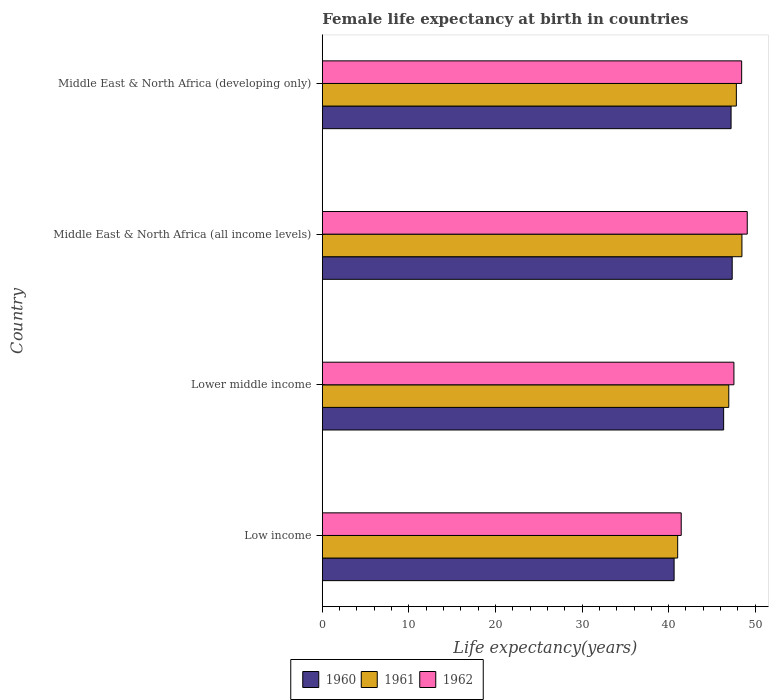How many different coloured bars are there?
Offer a very short reply. 3. How many groups of bars are there?
Provide a short and direct response. 4. How many bars are there on the 3rd tick from the top?
Your answer should be very brief. 3. How many bars are there on the 3rd tick from the bottom?
Offer a terse response. 3. What is the label of the 3rd group of bars from the top?
Provide a succinct answer. Lower middle income. What is the female life expectancy at birth in 1960 in Middle East & North Africa (developing only)?
Your answer should be very brief. 47.21. Across all countries, what is the maximum female life expectancy at birth in 1961?
Offer a terse response. 48.47. Across all countries, what is the minimum female life expectancy at birth in 1961?
Offer a terse response. 41.04. In which country was the female life expectancy at birth in 1960 maximum?
Provide a short and direct response. Middle East & North Africa (all income levels). In which country was the female life expectancy at birth in 1960 minimum?
Your answer should be compact. Low income. What is the total female life expectancy at birth in 1961 in the graph?
Give a very brief answer. 184.29. What is the difference between the female life expectancy at birth in 1960 in Middle East & North Africa (all income levels) and that in Middle East & North Africa (developing only)?
Offer a terse response. 0.13. What is the difference between the female life expectancy at birth in 1960 in Middle East & North Africa (developing only) and the female life expectancy at birth in 1962 in Low income?
Offer a terse response. 5.76. What is the average female life expectancy at birth in 1961 per country?
Keep it short and to the point. 46.07. What is the difference between the female life expectancy at birth in 1961 and female life expectancy at birth in 1960 in Low income?
Give a very brief answer. 0.41. What is the ratio of the female life expectancy at birth in 1960 in Lower middle income to that in Middle East & North Africa (all income levels)?
Provide a succinct answer. 0.98. What is the difference between the highest and the second highest female life expectancy at birth in 1962?
Ensure brevity in your answer.  0.65. What is the difference between the highest and the lowest female life expectancy at birth in 1960?
Ensure brevity in your answer.  6.71. What does the 1st bar from the top in Middle East & North Africa (all income levels) represents?
Ensure brevity in your answer.  1962. What does the 3rd bar from the bottom in Middle East & North Africa (all income levels) represents?
Provide a succinct answer. 1962. Are all the bars in the graph horizontal?
Keep it short and to the point. Yes. What is the difference between two consecutive major ticks on the X-axis?
Give a very brief answer. 10. Does the graph contain grids?
Keep it short and to the point. No. Where does the legend appear in the graph?
Give a very brief answer. Bottom center. What is the title of the graph?
Make the answer very short. Female life expectancy at birth in countries. What is the label or title of the X-axis?
Your answer should be very brief. Life expectancy(years). What is the label or title of the Y-axis?
Provide a succinct answer. Country. What is the Life expectancy(years) of 1960 in Low income?
Offer a very short reply. 40.63. What is the Life expectancy(years) in 1961 in Low income?
Ensure brevity in your answer.  41.04. What is the Life expectancy(years) in 1962 in Low income?
Your answer should be very brief. 41.46. What is the Life expectancy(years) in 1960 in Lower middle income?
Make the answer very short. 46.36. What is the Life expectancy(years) of 1961 in Lower middle income?
Ensure brevity in your answer.  46.95. What is the Life expectancy(years) in 1962 in Lower middle income?
Your answer should be compact. 47.54. What is the Life expectancy(years) in 1960 in Middle East & North Africa (all income levels)?
Keep it short and to the point. 47.34. What is the Life expectancy(years) in 1961 in Middle East & North Africa (all income levels)?
Your response must be concise. 48.47. What is the Life expectancy(years) of 1962 in Middle East & North Africa (all income levels)?
Offer a very short reply. 49.08. What is the Life expectancy(years) in 1960 in Middle East & North Africa (developing only)?
Provide a short and direct response. 47.21. What is the Life expectancy(years) of 1961 in Middle East & North Africa (developing only)?
Provide a succinct answer. 47.82. What is the Life expectancy(years) in 1962 in Middle East & North Africa (developing only)?
Make the answer very short. 48.44. Across all countries, what is the maximum Life expectancy(years) of 1960?
Offer a terse response. 47.34. Across all countries, what is the maximum Life expectancy(years) in 1961?
Offer a very short reply. 48.47. Across all countries, what is the maximum Life expectancy(years) of 1962?
Keep it short and to the point. 49.08. Across all countries, what is the minimum Life expectancy(years) in 1960?
Keep it short and to the point. 40.63. Across all countries, what is the minimum Life expectancy(years) in 1961?
Offer a very short reply. 41.04. Across all countries, what is the minimum Life expectancy(years) of 1962?
Make the answer very short. 41.46. What is the total Life expectancy(years) of 1960 in the graph?
Provide a succinct answer. 181.55. What is the total Life expectancy(years) in 1961 in the graph?
Your answer should be very brief. 184.29. What is the total Life expectancy(years) in 1962 in the graph?
Keep it short and to the point. 186.52. What is the difference between the Life expectancy(years) of 1960 in Low income and that in Lower middle income?
Provide a succinct answer. -5.72. What is the difference between the Life expectancy(years) of 1961 in Low income and that in Lower middle income?
Offer a very short reply. -5.9. What is the difference between the Life expectancy(years) in 1962 in Low income and that in Lower middle income?
Your answer should be compact. -6.09. What is the difference between the Life expectancy(years) of 1960 in Low income and that in Middle East & North Africa (all income levels)?
Your answer should be compact. -6.71. What is the difference between the Life expectancy(years) in 1961 in Low income and that in Middle East & North Africa (all income levels)?
Ensure brevity in your answer.  -7.42. What is the difference between the Life expectancy(years) in 1962 in Low income and that in Middle East & North Africa (all income levels)?
Make the answer very short. -7.63. What is the difference between the Life expectancy(years) of 1960 in Low income and that in Middle East & North Africa (developing only)?
Keep it short and to the point. -6.58. What is the difference between the Life expectancy(years) in 1961 in Low income and that in Middle East & North Africa (developing only)?
Provide a short and direct response. -6.78. What is the difference between the Life expectancy(years) in 1962 in Low income and that in Middle East & North Africa (developing only)?
Make the answer very short. -6.98. What is the difference between the Life expectancy(years) in 1960 in Lower middle income and that in Middle East & North Africa (all income levels)?
Make the answer very short. -0.99. What is the difference between the Life expectancy(years) of 1961 in Lower middle income and that in Middle East & North Africa (all income levels)?
Provide a short and direct response. -1.52. What is the difference between the Life expectancy(years) of 1962 in Lower middle income and that in Middle East & North Africa (all income levels)?
Ensure brevity in your answer.  -1.54. What is the difference between the Life expectancy(years) of 1960 in Lower middle income and that in Middle East & North Africa (developing only)?
Provide a succinct answer. -0.86. What is the difference between the Life expectancy(years) of 1961 in Lower middle income and that in Middle East & North Africa (developing only)?
Provide a succinct answer. -0.88. What is the difference between the Life expectancy(years) in 1962 in Lower middle income and that in Middle East & North Africa (developing only)?
Provide a short and direct response. -0.89. What is the difference between the Life expectancy(years) of 1960 in Middle East & North Africa (all income levels) and that in Middle East & North Africa (developing only)?
Offer a very short reply. 0.13. What is the difference between the Life expectancy(years) of 1961 in Middle East & North Africa (all income levels) and that in Middle East & North Africa (developing only)?
Offer a terse response. 0.64. What is the difference between the Life expectancy(years) in 1962 in Middle East & North Africa (all income levels) and that in Middle East & North Africa (developing only)?
Ensure brevity in your answer.  0.65. What is the difference between the Life expectancy(years) of 1960 in Low income and the Life expectancy(years) of 1961 in Lower middle income?
Keep it short and to the point. -6.32. What is the difference between the Life expectancy(years) in 1960 in Low income and the Life expectancy(years) in 1962 in Lower middle income?
Provide a short and direct response. -6.91. What is the difference between the Life expectancy(years) of 1961 in Low income and the Life expectancy(years) of 1962 in Lower middle income?
Offer a terse response. -6.5. What is the difference between the Life expectancy(years) in 1960 in Low income and the Life expectancy(years) in 1961 in Middle East & North Africa (all income levels)?
Your answer should be compact. -7.84. What is the difference between the Life expectancy(years) in 1960 in Low income and the Life expectancy(years) in 1962 in Middle East & North Africa (all income levels)?
Make the answer very short. -8.45. What is the difference between the Life expectancy(years) of 1961 in Low income and the Life expectancy(years) of 1962 in Middle East & North Africa (all income levels)?
Offer a very short reply. -8.04. What is the difference between the Life expectancy(years) of 1960 in Low income and the Life expectancy(years) of 1961 in Middle East & North Africa (developing only)?
Your response must be concise. -7.19. What is the difference between the Life expectancy(years) of 1960 in Low income and the Life expectancy(years) of 1962 in Middle East & North Africa (developing only)?
Your response must be concise. -7.8. What is the difference between the Life expectancy(years) in 1961 in Low income and the Life expectancy(years) in 1962 in Middle East & North Africa (developing only)?
Provide a succinct answer. -7.39. What is the difference between the Life expectancy(years) in 1960 in Lower middle income and the Life expectancy(years) in 1961 in Middle East & North Africa (all income levels)?
Your answer should be compact. -2.11. What is the difference between the Life expectancy(years) in 1960 in Lower middle income and the Life expectancy(years) in 1962 in Middle East & North Africa (all income levels)?
Offer a very short reply. -2.73. What is the difference between the Life expectancy(years) of 1961 in Lower middle income and the Life expectancy(years) of 1962 in Middle East & North Africa (all income levels)?
Provide a short and direct response. -2.13. What is the difference between the Life expectancy(years) of 1960 in Lower middle income and the Life expectancy(years) of 1961 in Middle East & North Africa (developing only)?
Ensure brevity in your answer.  -1.47. What is the difference between the Life expectancy(years) in 1960 in Lower middle income and the Life expectancy(years) in 1962 in Middle East & North Africa (developing only)?
Keep it short and to the point. -2.08. What is the difference between the Life expectancy(years) of 1961 in Lower middle income and the Life expectancy(years) of 1962 in Middle East & North Africa (developing only)?
Provide a succinct answer. -1.49. What is the difference between the Life expectancy(years) of 1960 in Middle East & North Africa (all income levels) and the Life expectancy(years) of 1961 in Middle East & North Africa (developing only)?
Make the answer very short. -0.48. What is the difference between the Life expectancy(years) of 1960 in Middle East & North Africa (all income levels) and the Life expectancy(years) of 1962 in Middle East & North Africa (developing only)?
Give a very brief answer. -1.09. What is the difference between the Life expectancy(years) of 1961 in Middle East & North Africa (all income levels) and the Life expectancy(years) of 1962 in Middle East & North Africa (developing only)?
Your response must be concise. 0.03. What is the average Life expectancy(years) of 1960 per country?
Offer a terse response. 45.39. What is the average Life expectancy(years) in 1961 per country?
Give a very brief answer. 46.07. What is the average Life expectancy(years) in 1962 per country?
Your response must be concise. 46.63. What is the difference between the Life expectancy(years) in 1960 and Life expectancy(years) in 1961 in Low income?
Keep it short and to the point. -0.41. What is the difference between the Life expectancy(years) in 1960 and Life expectancy(years) in 1962 in Low income?
Ensure brevity in your answer.  -0.82. What is the difference between the Life expectancy(years) in 1961 and Life expectancy(years) in 1962 in Low income?
Provide a succinct answer. -0.41. What is the difference between the Life expectancy(years) of 1960 and Life expectancy(years) of 1961 in Lower middle income?
Make the answer very short. -0.59. What is the difference between the Life expectancy(years) in 1960 and Life expectancy(years) in 1962 in Lower middle income?
Make the answer very short. -1.19. What is the difference between the Life expectancy(years) in 1961 and Life expectancy(years) in 1962 in Lower middle income?
Ensure brevity in your answer.  -0.59. What is the difference between the Life expectancy(years) of 1960 and Life expectancy(years) of 1961 in Middle East & North Africa (all income levels)?
Keep it short and to the point. -1.13. What is the difference between the Life expectancy(years) in 1960 and Life expectancy(years) in 1962 in Middle East & North Africa (all income levels)?
Provide a succinct answer. -1.74. What is the difference between the Life expectancy(years) in 1961 and Life expectancy(years) in 1962 in Middle East & North Africa (all income levels)?
Provide a short and direct response. -0.61. What is the difference between the Life expectancy(years) in 1960 and Life expectancy(years) in 1961 in Middle East & North Africa (developing only)?
Your answer should be compact. -0.61. What is the difference between the Life expectancy(years) of 1960 and Life expectancy(years) of 1962 in Middle East & North Africa (developing only)?
Provide a succinct answer. -1.22. What is the difference between the Life expectancy(years) of 1961 and Life expectancy(years) of 1962 in Middle East & North Africa (developing only)?
Provide a succinct answer. -0.61. What is the ratio of the Life expectancy(years) of 1960 in Low income to that in Lower middle income?
Ensure brevity in your answer.  0.88. What is the ratio of the Life expectancy(years) in 1961 in Low income to that in Lower middle income?
Your response must be concise. 0.87. What is the ratio of the Life expectancy(years) of 1962 in Low income to that in Lower middle income?
Your answer should be very brief. 0.87. What is the ratio of the Life expectancy(years) in 1960 in Low income to that in Middle East & North Africa (all income levels)?
Provide a short and direct response. 0.86. What is the ratio of the Life expectancy(years) in 1961 in Low income to that in Middle East & North Africa (all income levels)?
Provide a succinct answer. 0.85. What is the ratio of the Life expectancy(years) of 1962 in Low income to that in Middle East & North Africa (all income levels)?
Your response must be concise. 0.84. What is the ratio of the Life expectancy(years) of 1960 in Low income to that in Middle East & North Africa (developing only)?
Your response must be concise. 0.86. What is the ratio of the Life expectancy(years) in 1961 in Low income to that in Middle East & North Africa (developing only)?
Make the answer very short. 0.86. What is the ratio of the Life expectancy(years) of 1962 in Low income to that in Middle East & North Africa (developing only)?
Your response must be concise. 0.86. What is the ratio of the Life expectancy(years) of 1960 in Lower middle income to that in Middle East & North Africa (all income levels)?
Offer a terse response. 0.98. What is the ratio of the Life expectancy(years) of 1961 in Lower middle income to that in Middle East & North Africa (all income levels)?
Give a very brief answer. 0.97. What is the ratio of the Life expectancy(years) of 1962 in Lower middle income to that in Middle East & North Africa (all income levels)?
Your answer should be very brief. 0.97. What is the ratio of the Life expectancy(years) in 1960 in Lower middle income to that in Middle East & North Africa (developing only)?
Provide a short and direct response. 0.98. What is the ratio of the Life expectancy(years) in 1961 in Lower middle income to that in Middle East & North Africa (developing only)?
Provide a short and direct response. 0.98. What is the ratio of the Life expectancy(years) of 1962 in Lower middle income to that in Middle East & North Africa (developing only)?
Give a very brief answer. 0.98. What is the ratio of the Life expectancy(years) of 1960 in Middle East & North Africa (all income levels) to that in Middle East & North Africa (developing only)?
Offer a very short reply. 1. What is the ratio of the Life expectancy(years) in 1961 in Middle East & North Africa (all income levels) to that in Middle East & North Africa (developing only)?
Ensure brevity in your answer.  1.01. What is the ratio of the Life expectancy(years) of 1962 in Middle East & North Africa (all income levels) to that in Middle East & North Africa (developing only)?
Ensure brevity in your answer.  1.01. What is the difference between the highest and the second highest Life expectancy(years) in 1960?
Provide a succinct answer. 0.13. What is the difference between the highest and the second highest Life expectancy(years) of 1961?
Offer a terse response. 0.64. What is the difference between the highest and the second highest Life expectancy(years) in 1962?
Your answer should be very brief. 0.65. What is the difference between the highest and the lowest Life expectancy(years) of 1960?
Ensure brevity in your answer.  6.71. What is the difference between the highest and the lowest Life expectancy(years) in 1961?
Give a very brief answer. 7.42. What is the difference between the highest and the lowest Life expectancy(years) of 1962?
Offer a terse response. 7.63. 